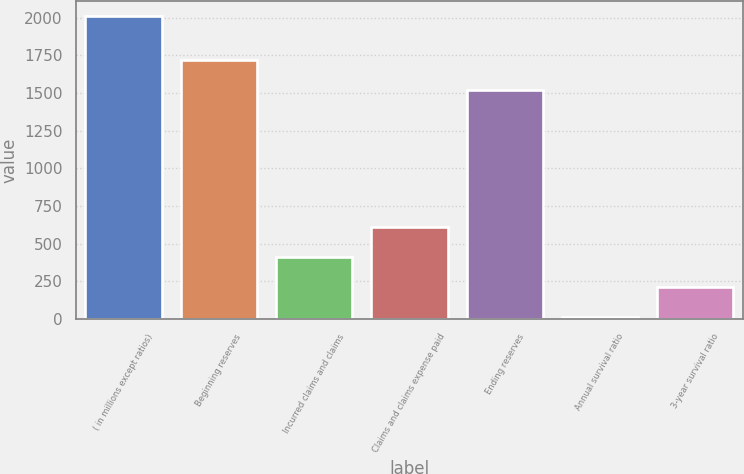<chart> <loc_0><loc_0><loc_500><loc_500><bar_chart><fcel>( in millions except ratios)<fcel>Beginning reserves<fcel>Incurred claims and claims<fcel>Claims and claims expense paid<fcel>Ending reserves<fcel>Annual survival ratio<fcel>3-year survival ratio<nl><fcel>2012<fcel>1721.92<fcel>412.64<fcel>612.56<fcel>1522<fcel>12.8<fcel>212.72<nl></chart> 